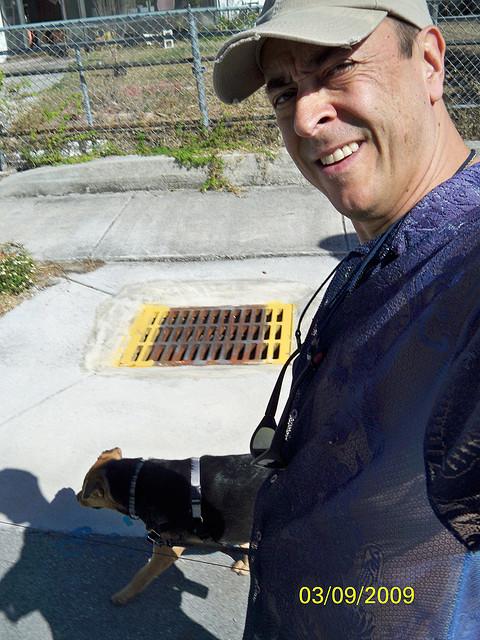What is the man with the blue shirt doing?
Write a very short answer. Walking dog. Is the man listening to music?
Answer briefly. No. What color is the man's sweatshirt?
Write a very short answer. Blue. Is that Mike Rowe from hit TV show World's Dirtiest Jobs?
Short answer required. No. What is the date on the photo?
Be succinct. 03/09/2009. What type of fence is around the yard?
Give a very brief answer. Chain link. What number is seen on the image?
Answer briefly. 03/09/2009. 